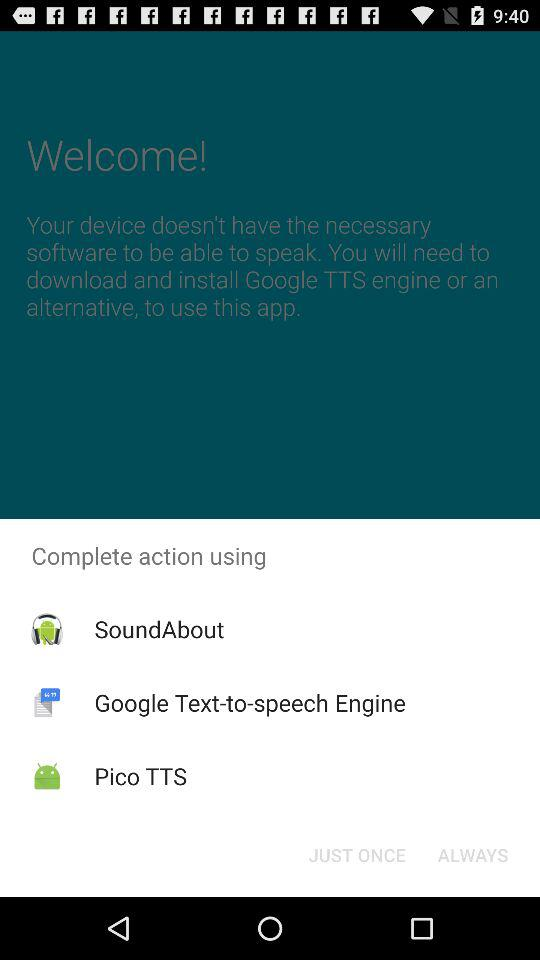What applications can be used to complete the action? The applications "SoundAbout", "Google Text-to-speech Engine" and "Pico TTS" can be used to complete the action. 